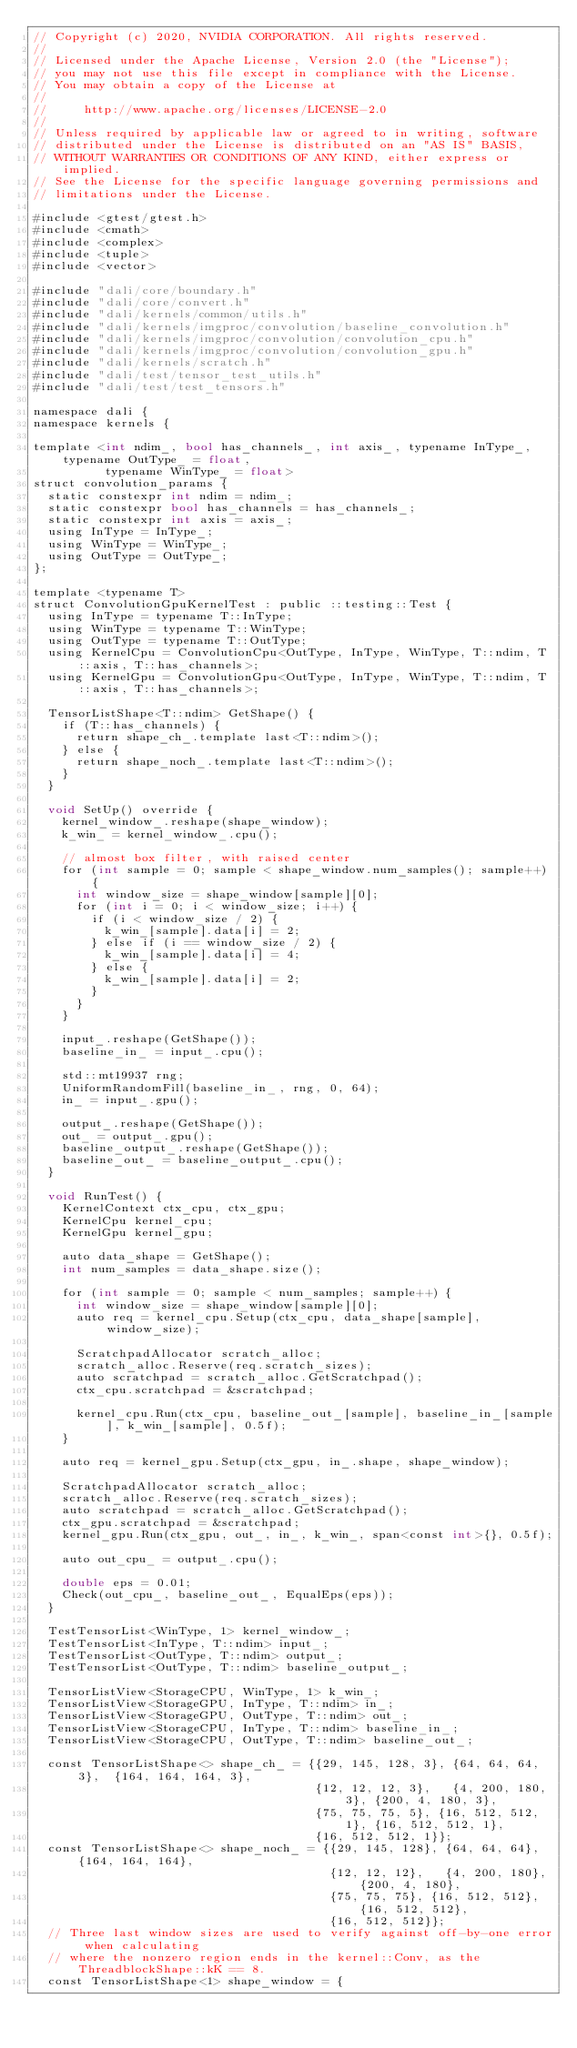<code> <loc_0><loc_0><loc_500><loc_500><_Cuda_>// Copyright (c) 2020, NVIDIA CORPORATION. All rights reserved.
//
// Licensed under the Apache License, Version 2.0 (the "License");
// you may not use this file except in compliance with the License.
// You may obtain a copy of the License at
//
//     http://www.apache.org/licenses/LICENSE-2.0
//
// Unless required by applicable law or agreed to in writing, software
// distributed under the License is distributed on an "AS IS" BASIS,
// WITHOUT WARRANTIES OR CONDITIONS OF ANY KIND, either express or implied.
// See the License for the specific language governing permissions and
// limitations under the License.

#include <gtest/gtest.h>
#include <cmath>
#include <complex>
#include <tuple>
#include <vector>

#include "dali/core/boundary.h"
#include "dali/core/convert.h"
#include "dali/kernels/common/utils.h"
#include "dali/kernels/imgproc/convolution/baseline_convolution.h"
#include "dali/kernels/imgproc/convolution/convolution_cpu.h"
#include "dali/kernels/imgproc/convolution/convolution_gpu.h"
#include "dali/kernels/scratch.h"
#include "dali/test/tensor_test_utils.h"
#include "dali/test/test_tensors.h"

namespace dali {
namespace kernels {

template <int ndim_, bool has_channels_, int axis_, typename InType_, typename OutType_ = float,
          typename WinType_ = float>
struct convolution_params {
  static constexpr int ndim = ndim_;
  static constexpr bool has_channels = has_channels_;
  static constexpr int axis = axis_;
  using InType = InType_;
  using WinType = WinType_;
  using OutType = OutType_;
};

template <typename T>
struct ConvolutionGpuKernelTest : public ::testing::Test {
  using InType = typename T::InType;
  using WinType = typename T::WinType;
  using OutType = typename T::OutType;
  using KernelCpu = ConvolutionCpu<OutType, InType, WinType, T::ndim, T::axis, T::has_channels>;
  using KernelGpu = ConvolutionGpu<OutType, InType, WinType, T::ndim, T::axis, T::has_channels>;

  TensorListShape<T::ndim> GetShape() {
    if (T::has_channels) {
      return shape_ch_.template last<T::ndim>();
    } else {
      return shape_noch_.template last<T::ndim>();
    }
  }

  void SetUp() override {
    kernel_window_.reshape(shape_window);
    k_win_ = kernel_window_.cpu();

    // almost box filter, with raised center
    for (int sample = 0; sample < shape_window.num_samples(); sample++) {
      int window_size = shape_window[sample][0];
      for (int i = 0; i < window_size; i++) {
        if (i < window_size / 2) {
          k_win_[sample].data[i] = 2;
        } else if (i == window_size / 2) {
          k_win_[sample].data[i] = 4;
        } else {
          k_win_[sample].data[i] = 2;
        }
      }
    }

    input_.reshape(GetShape());
    baseline_in_ = input_.cpu();

    std::mt19937 rng;
    UniformRandomFill(baseline_in_, rng, 0, 64);
    in_ = input_.gpu();

    output_.reshape(GetShape());
    out_ = output_.gpu();
    baseline_output_.reshape(GetShape());
    baseline_out_ = baseline_output_.cpu();
  }

  void RunTest() {
    KernelContext ctx_cpu, ctx_gpu;
    KernelCpu kernel_cpu;
    KernelGpu kernel_gpu;

    auto data_shape = GetShape();
    int num_samples = data_shape.size();

    for (int sample = 0; sample < num_samples; sample++) {
      int window_size = shape_window[sample][0];
      auto req = kernel_cpu.Setup(ctx_cpu, data_shape[sample], window_size);

      ScratchpadAllocator scratch_alloc;
      scratch_alloc.Reserve(req.scratch_sizes);
      auto scratchpad = scratch_alloc.GetScratchpad();
      ctx_cpu.scratchpad = &scratchpad;

      kernel_cpu.Run(ctx_cpu, baseline_out_[sample], baseline_in_[sample], k_win_[sample], 0.5f);
    }

    auto req = kernel_gpu.Setup(ctx_gpu, in_.shape, shape_window);

    ScratchpadAllocator scratch_alloc;
    scratch_alloc.Reserve(req.scratch_sizes);
    auto scratchpad = scratch_alloc.GetScratchpad();
    ctx_gpu.scratchpad = &scratchpad;
    kernel_gpu.Run(ctx_gpu, out_, in_, k_win_, span<const int>{}, 0.5f);

    auto out_cpu_ = output_.cpu();

    double eps = 0.01;
    Check(out_cpu_, baseline_out_, EqualEps(eps));
  }

  TestTensorList<WinType, 1> kernel_window_;
  TestTensorList<InType, T::ndim> input_;
  TestTensorList<OutType, T::ndim> output_;
  TestTensorList<OutType, T::ndim> baseline_output_;

  TensorListView<StorageCPU, WinType, 1> k_win_;
  TensorListView<StorageGPU, InType, T::ndim> in_;
  TensorListView<StorageGPU, OutType, T::ndim> out_;
  TensorListView<StorageCPU, InType, T::ndim> baseline_in_;
  TensorListView<StorageCPU, OutType, T::ndim> baseline_out_;

  const TensorListShape<> shape_ch_ = {{29, 145, 128, 3}, {64, 64, 64, 3},  {164, 164, 164, 3},
                                       {12, 12, 12, 3},   {4, 200, 180, 3}, {200, 4, 180, 3},
                                       {75, 75, 75, 5}, {16, 512, 512, 1}, {16, 512, 512, 1},
                                       {16, 512, 512, 1}};
  const TensorListShape<> shape_noch_ = {{29, 145, 128}, {64, 64, 64},  {164, 164, 164},
                                         {12, 12, 12},   {4, 200, 180}, {200, 4, 180},
                                         {75, 75, 75}, {16, 512, 512}, {16, 512, 512},
                                         {16, 512, 512}};
  // Three last window sizes are used to verify against off-by-one error when calculating
  // where the nonzero region ends in the kernel::Conv, as the ThreadblockShape::kK == 8.
  const TensorListShape<1> shape_window = {</code> 